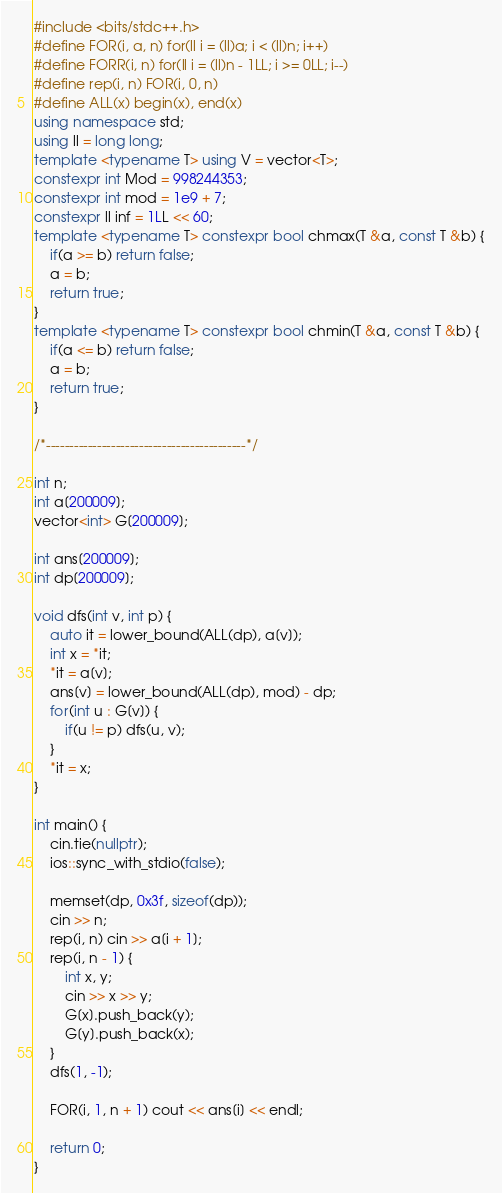<code> <loc_0><loc_0><loc_500><loc_500><_C++_>#include <bits/stdc++.h>
#define FOR(i, a, n) for(ll i = (ll)a; i < (ll)n; i++)
#define FORR(i, n) for(ll i = (ll)n - 1LL; i >= 0LL; i--)
#define rep(i, n) FOR(i, 0, n)
#define ALL(x) begin(x), end(x)
using namespace std;
using ll = long long;
template <typename T> using V = vector<T>;
constexpr int Mod = 998244353;
constexpr int mod = 1e9 + 7;
constexpr ll inf = 1LL << 60;
template <typename T> constexpr bool chmax(T &a, const T &b) {
    if(a >= b) return false;
    a = b;
    return true;
}
template <typename T> constexpr bool chmin(T &a, const T &b) {
    if(a <= b) return false;
    a = b;
    return true;
}

/*-------------------------------------------*/

int n;
int a[200009];
vector<int> G[200009];

int ans[200009];
int dp[200009];

void dfs(int v, int p) {
    auto it = lower_bound(ALL(dp), a[v]);
    int x = *it;
    *it = a[v];
    ans[v] = lower_bound(ALL(dp), mod) - dp;
    for(int u : G[v]) {
        if(u != p) dfs(u, v);
    }
    *it = x;
}

int main() {
    cin.tie(nullptr);
    ios::sync_with_stdio(false);

    memset(dp, 0x3f, sizeof(dp));
    cin >> n;
    rep(i, n) cin >> a[i + 1];
    rep(i, n - 1) {
        int x, y;
        cin >> x >> y;
        G[x].push_back(y);
        G[y].push_back(x);
    }
    dfs(1, -1);

    FOR(i, 1, n + 1) cout << ans[i] << endl;

    return 0;
}</code> 